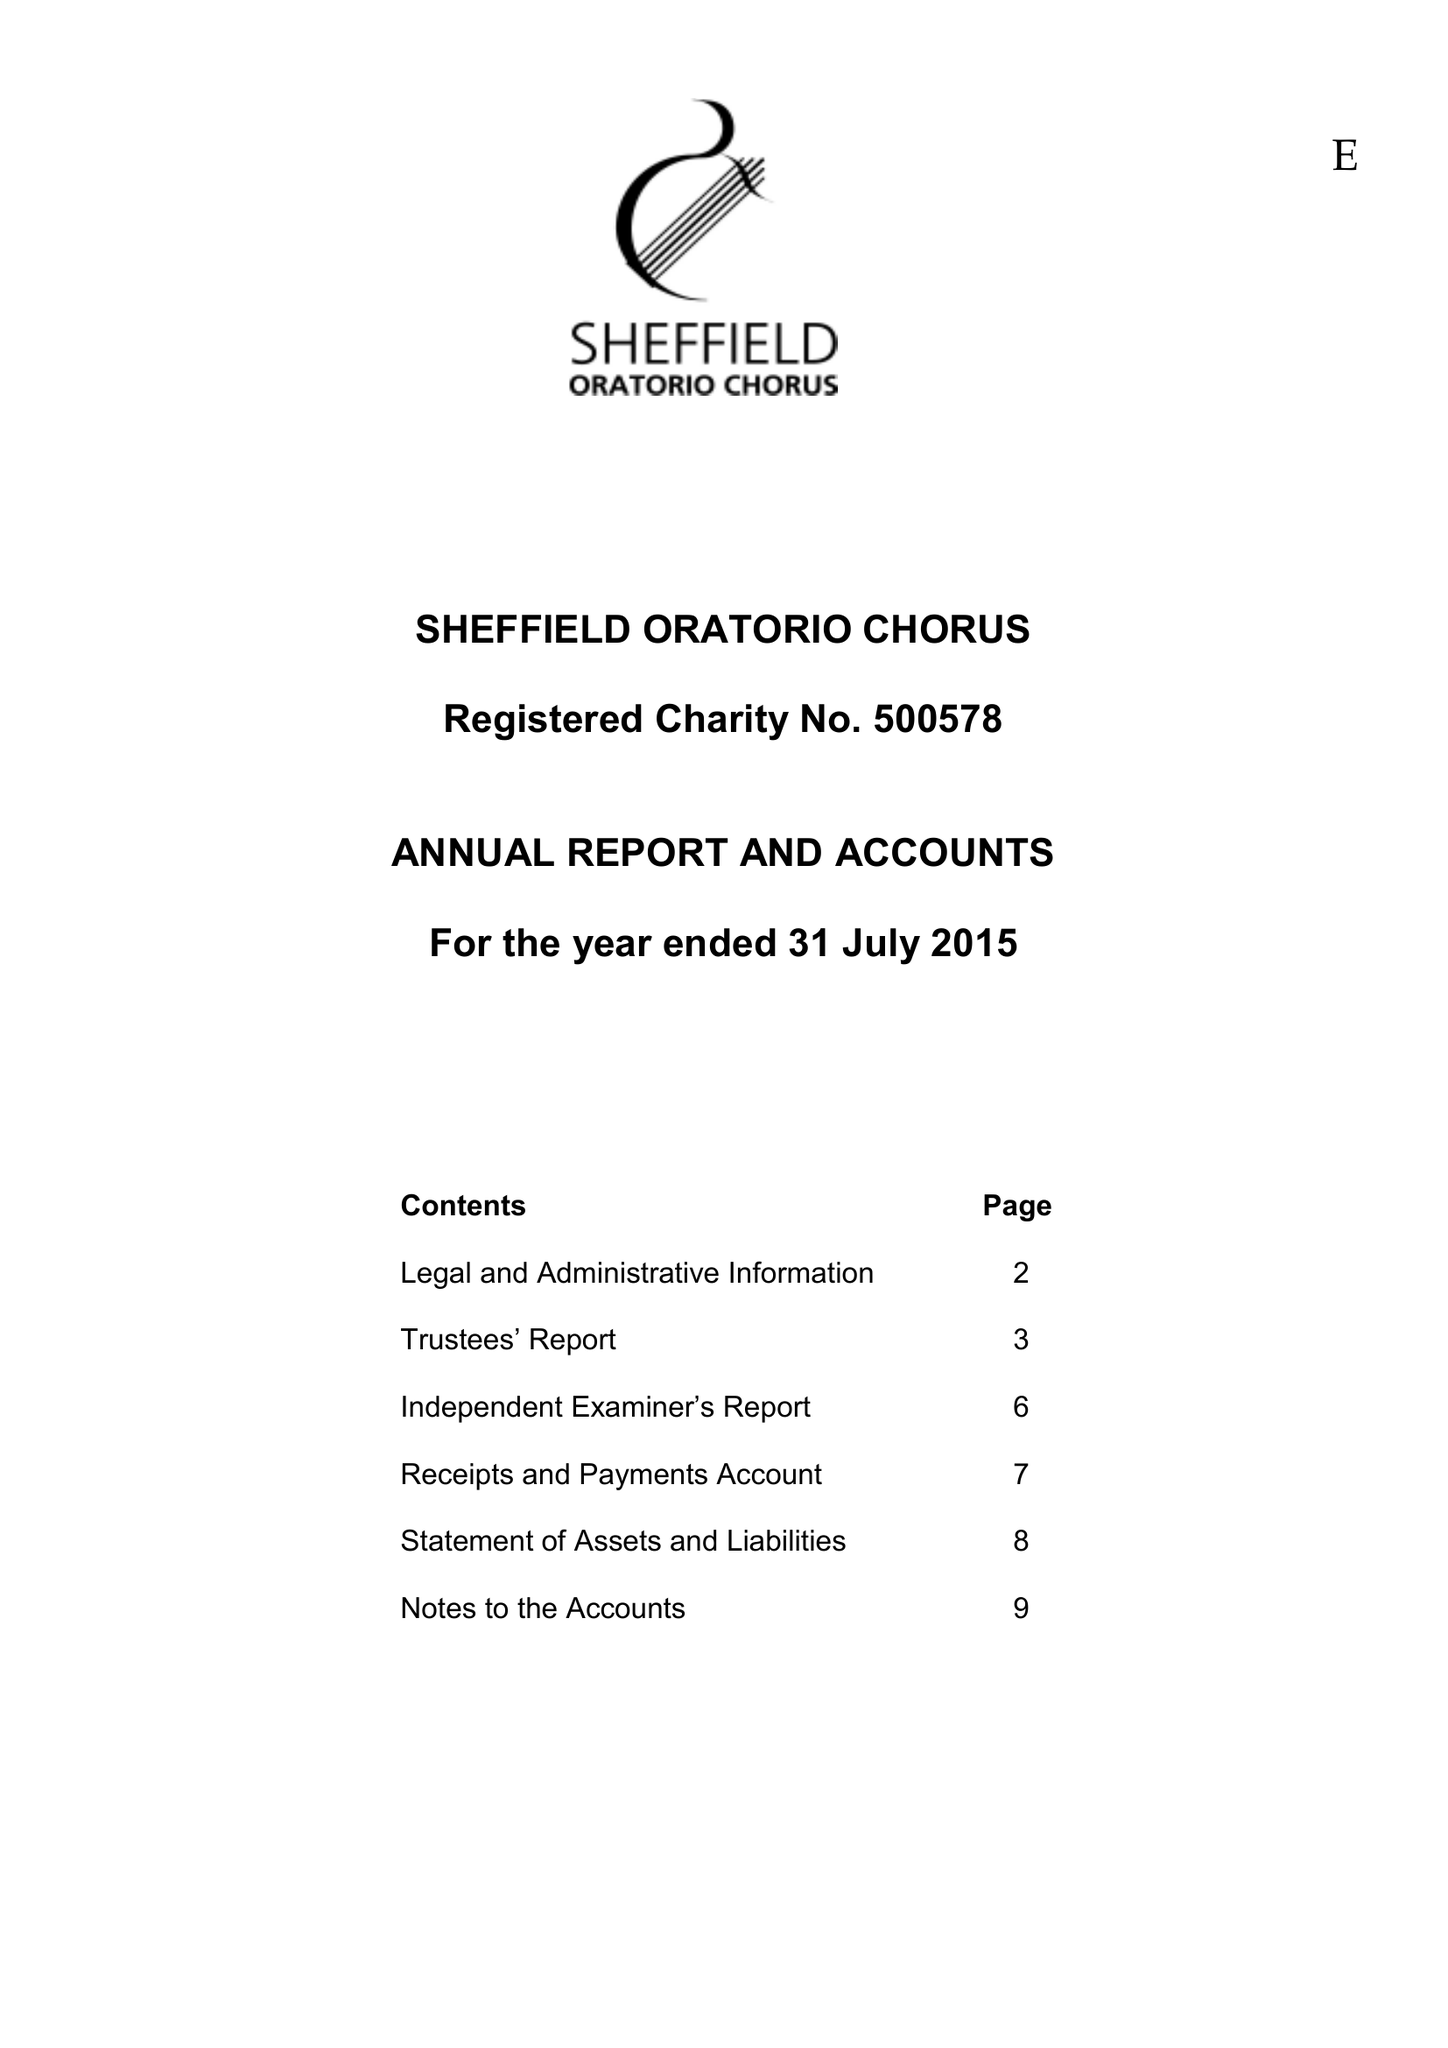What is the value for the charity_number?
Answer the question using a single word or phrase. 500578 